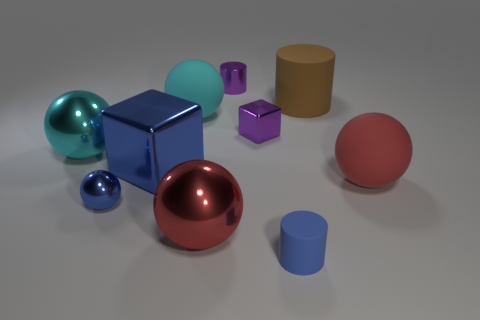Subtract all blue spheres. How many spheres are left? 4 Subtract all small metallic spheres. How many spheres are left? 4 Subtract all gray spheres. Subtract all yellow cubes. How many spheres are left? 5 Subtract all cylinders. How many objects are left? 7 Add 6 big rubber things. How many big rubber things are left? 9 Add 4 tiny blue metal things. How many tiny blue metal things exist? 5 Subtract 1 red spheres. How many objects are left? 9 Subtract all tiny purple cubes. Subtract all purple metal cylinders. How many objects are left? 8 